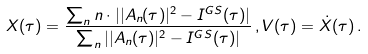<formula> <loc_0><loc_0><loc_500><loc_500>X ( \tau ) = \frac { \sum _ { n } n \cdot | | A _ { n } ( \tau ) | ^ { 2 } - I ^ { G S } ( \tau ) | } { \sum _ { n } | | A _ { n } ( \tau ) | ^ { 2 } - I ^ { G S } ( \tau ) | } \, , V ( \tau ) = \dot { X } ( \tau ) \, .</formula> 